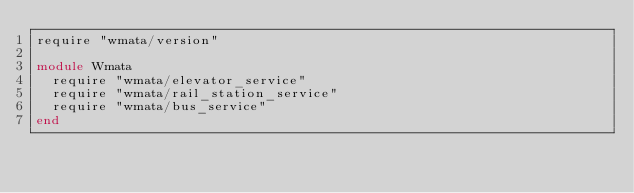Convert code to text. <code><loc_0><loc_0><loc_500><loc_500><_Ruby_>require "wmata/version"

module Wmata
  require "wmata/elevator_service"
  require "wmata/rail_station_service"
  require "wmata/bus_service"
end
</code> 